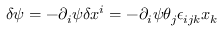Convert formula to latex. <formula><loc_0><loc_0><loc_500><loc_500>\delta \psi = - \partial _ { i } \psi \delta x ^ { i } = - \partial _ { i } \psi \theta _ { j } \epsilon _ { i j k } x _ { k }</formula> 